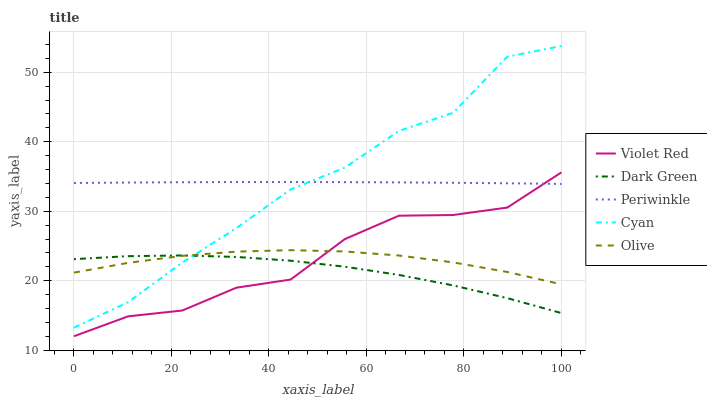Does Dark Green have the minimum area under the curve?
Answer yes or no. Yes. Does Cyan have the maximum area under the curve?
Answer yes or no. Yes. Does Violet Red have the minimum area under the curve?
Answer yes or no. No. Does Violet Red have the maximum area under the curve?
Answer yes or no. No. Is Periwinkle the smoothest?
Answer yes or no. Yes. Is Cyan the roughest?
Answer yes or no. Yes. Is Violet Red the smoothest?
Answer yes or no. No. Is Violet Red the roughest?
Answer yes or no. No. Does Violet Red have the lowest value?
Answer yes or no. Yes. Does Cyan have the lowest value?
Answer yes or no. No. Does Cyan have the highest value?
Answer yes or no. Yes. Does Violet Red have the highest value?
Answer yes or no. No. Is Olive less than Periwinkle?
Answer yes or no. Yes. Is Periwinkle greater than Olive?
Answer yes or no. Yes. Does Periwinkle intersect Violet Red?
Answer yes or no. Yes. Is Periwinkle less than Violet Red?
Answer yes or no. No. Is Periwinkle greater than Violet Red?
Answer yes or no. No. Does Olive intersect Periwinkle?
Answer yes or no. No. 